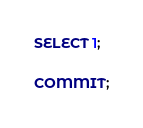Convert code to text. <code><loc_0><loc_0><loc_500><loc_500><_SQL_>
SELECT 1;

COMMIT;
</code> 